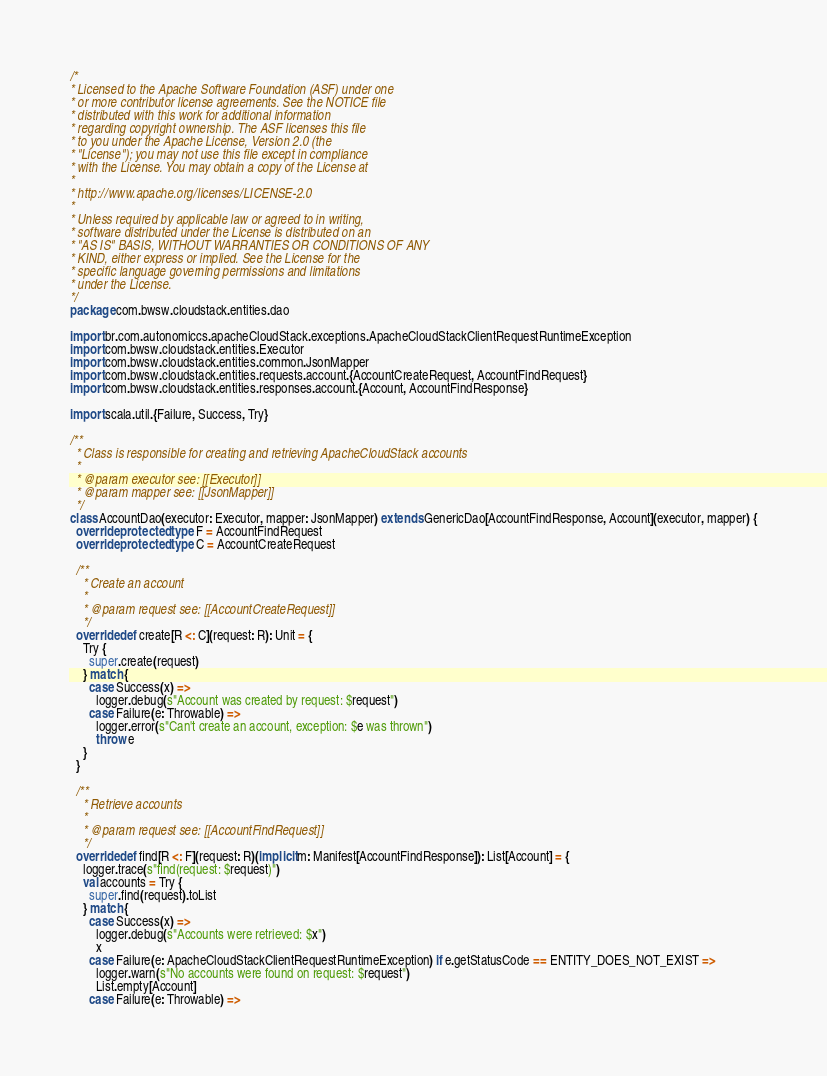Convert code to text. <code><loc_0><loc_0><loc_500><loc_500><_Scala_>/*
* Licensed to the Apache Software Foundation (ASF) under one
* or more contributor license agreements. See the NOTICE file
* distributed with this work for additional information
* regarding copyright ownership. The ASF licenses this file
* to you under the Apache License, Version 2.0 (the
* "License"); you may not use this file except in compliance
* with the License. You may obtain a copy of the License at
*
* http://www.apache.org/licenses/LICENSE-2.0
*
* Unless required by applicable law or agreed to in writing,
* software distributed under the License is distributed on an
* "AS IS" BASIS, WITHOUT WARRANTIES OR CONDITIONS OF ANY
* KIND, either express or implied. See the License for the
* specific language governing permissions and limitations
* under the License.
*/
package com.bwsw.cloudstack.entities.dao

import br.com.autonomiccs.apacheCloudStack.exceptions.ApacheCloudStackClientRequestRuntimeException
import com.bwsw.cloudstack.entities.Executor
import com.bwsw.cloudstack.entities.common.JsonMapper
import com.bwsw.cloudstack.entities.requests.account.{AccountCreateRequest, AccountFindRequest}
import com.bwsw.cloudstack.entities.responses.account.{Account, AccountFindResponse}

import scala.util.{Failure, Success, Try}

/**
  * Class is responsible for creating and retrieving ApacheCloudStack accounts
  *
  * @param executor see: [[Executor]]
  * @param mapper see: [[JsonMapper]]
  */
class AccountDao(executor: Executor, mapper: JsonMapper) extends GenericDao[AccountFindResponse, Account](executor, mapper) {
  override protected type F = AccountFindRequest
  override protected type C = AccountCreateRequest

  /**
    * Create an account
    *
    * @param request see: [[AccountCreateRequest]]
    */
  override def create[R <: C](request: R): Unit = {
    Try {
      super.create(request)
    } match {
      case Success(x) =>
        logger.debug(s"Account was created by request: $request")
      case Failure(e: Throwable) =>
        logger.error(s"Can't create an account, exception: $e was thrown")
        throw e
    }
  }

  /**
    * Retrieve accounts
    *
    * @param request see: [[AccountFindRequest]]
    */
  override def find[R <: F](request: R)(implicit m: Manifest[AccountFindResponse]): List[Account] = {
    logger.trace(s"find(request: $request)")
    val accounts = Try {
      super.find(request).toList
    } match {
      case Success(x) =>
        logger.debug(s"Accounts were retrieved: $x")
        x
      case Failure(e: ApacheCloudStackClientRequestRuntimeException) if e.getStatusCode == ENTITY_DOES_NOT_EXIST =>
        logger.warn(s"No accounts were found on request: $request")
        List.empty[Account]
      case Failure(e: Throwable) =></code> 